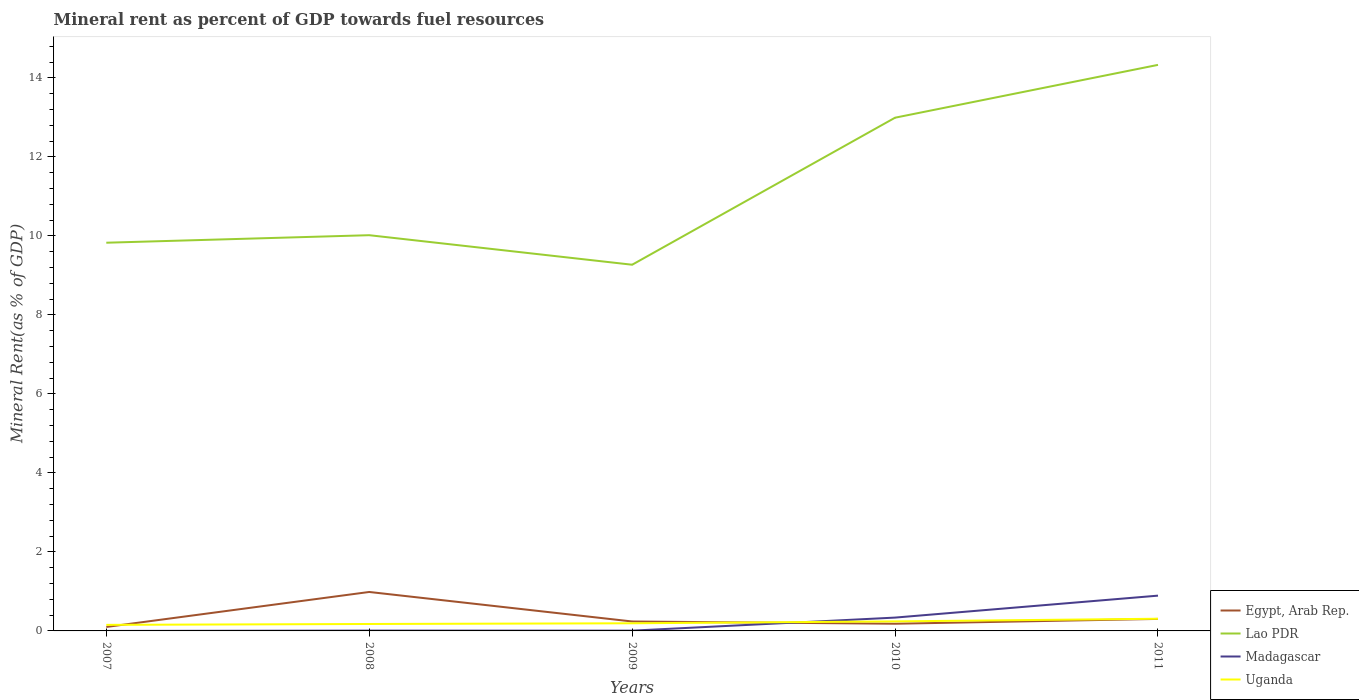Across all years, what is the maximum mineral rent in Lao PDR?
Keep it short and to the point. 9.27. In which year was the mineral rent in Madagascar maximum?
Provide a short and direct response. 2007. What is the total mineral rent in Egypt, Arab Rep. in the graph?
Provide a short and direct response. 0.68. What is the difference between the highest and the second highest mineral rent in Egypt, Arab Rep.?
Provide a succinct answer. 0.89. What is the difference between the highest and the lowest mineral rent in Madagascar?
Give a very brief answer. 2. Is the mineral rent in Lao PDR strictly greater than the mineral rent in Egypt, Arab Rep. over the years?
Offer a very short reply. No. Are the values on the major ticks of Y-axis written in scientific E-notation?
Provide a succinct answer. No. How are the legend labels stacked?
Your answer should be compact. Vertical. What is the title of the graph?
Offer a very short reply. Mineral rent as percent of GDP towards fuel resources. What is the label or title of the X-axis?
Offer a very short reply. Years. What is the label or title of the Y-axis?
Your answer should be very brief. Mineral Rent(as % of GDP). What is the Mineral Rent(as % of GDP) in Egypt, Arab Rep. in 2007?
Make the answer very short. 0.1. What is the Mineral Rent(as % of GDP) of Lao PDR in 2007?
Ensure brevity in your answer.  9.83. What is the Mineral Rent(as % of GDP) in Madagascar in 2007?
Give a very brief answer. 0. What is the Mineral Rent(as % of GDP) in Uganda in 2007?
Ensure brevity in your answer.  0.15. What is the Mineral Rent(as % of GDP) of Egypt, Arab Rep. in 2008?
Offer a very short reply. 0.99. What is the Mineral Rent(as % of GDP) in Lao PDR in 2008?
Provide a short and direct response. 10.02. What is the Mineral Rent(as % of GDP) in Madagascar in 2008?
Offer a very short reply. 0.01. What is the Mineral Rent(as % of GDP) in Uganda in 2008?
Your response must be concise. 0.18. What is the Mineral Rent(as % of GDP) in Egypt, Arab Rep. in 2009?
Provide a succinct answer. 0.24. What is the Mineral Rent(as % of GDP) in Lao PDR in 2009?
Provide a short and direct response. 9.27. What is the Mineral Rent(as % of GDP) in Madagascar in 2009?
Offer a very short reply. 0.01. What is the Mineral Rent(as % of GDP) of Uganda in 2009?
Keep it short and to the point. 0.19. What is the Mineral Rent(as % of GDP) of Egypt, Arab Rep. in 2010?
Your answer should be compact. 0.18. What is the Mineral Rent(as % of GDP) of Lao PDR in 2010?
Offer a very short reply. 12.99. What is the Mineral Rent(as % of GDP) in Madagascar in 2010?
Your response must be concise. 0.34. What is the Mineral Rent(as % of GDP) of Uganda in 2010?
Your response must be concise. 0.24. What is the Mineral Rent(as % of GDP) of Egypt, Arab Rep. in 2011?
Offer a terse response. 0.3. What is the Mineral Rent(as % of GDP) in Lao PDR in 2011?
Provide a succinct answer. 14.33. What is the Mineral Rent(as % of GDP) of Madagascar in 2011?
Keep it short and to the point. 0.89. What is the Mineral Rent(as % of GDP) of Uganda in 2011?
Offer a very short reply. 0.31. Across all years, what is the maximum Mineral Rent(as % of GDP) in Egypt, Arab Rep.?
Provide a short and direct response. 0.99. Across all years, what is the maximum Mineral Rent(as % of GDP) in Lao PDR?
Ensure brevity in your answer.  14.33. Across all years, what is the maximum Mineral Rent(as % of GDP) in Madagascar?
Offer a terse response. 0.89. Across all years, what is the maximum Mineral Rent(as % of GDP) in Uganda?
Provide a succinct answer. 0.31. Across all years, what is the minimum Mineral Rent(as % of GDP) of Egypt, Arab Rep.?
Offer a terse response. 0.1. Across all years, what is the minimum Mineral Rent(as % of GDP) in Lao PDR?
Your answer should be compact. 9.27. Across all years, what is the minimum Mineral Rent(as % of GDP) in Madagascar?
Your response must be concise. 0. Across all years, what is the minimum Mineral Rent(as % of GDP) of Uganda?
Offer a terse response. 0.15. What is the total Mineral Rent(as % of GDP) of Egypt, Arab Rep. in the graph?
Provide a short and direct response. 1.81. What is the total Mineral Rent(as % of GDP) of Lao PDR in the graph?
Offer a very short reply. 56.43. What is the total Mineral Rent(as % of GDP) in Madagascar in the graph?
Ensure brevity in your answer.  1.25. What is the total Mineral Rent(as % of GDP) in Uganda in the graph?
Offer a very short reply. 1.07. What is the difference between the Mineral Rent(as % of GDP) of Egypt, Arab Rep. in 2007 and that in 2008?
Offer a terse response. -0.89. What is the difference between the Mineral Rent(as % of GDP) of Lao PDR in 2007 and that in 2008?
Your answer should be very brief. -0.19. What is the difference between the Mineral Rent(as % of GDP) in Madagascar in 2007 and that in 2008?
Your answer should be compact. -0.01. What is the difference between the Mineral Rent(as % of GDP) of Uganda in 2007 and that in 2008?
Your response must be concise. -0.02. What is the difference between the Mineral Rent(as % of GDP) in Egypt, Arab Rep. in 2007 and that in 2009?
Offer a very short reply. -0.14. What is the difference between the Mineral Rent(as % of GDP) in Lao PDR in 2007 and that in 2009?
Make the answer very short. 0.56. What is the difference between the Mineral Rent(as % of GDP) of Madagascar in 2007 and that in 2009?
Your response must be concise. -0.01. What is the difference between the Mineral Rent(as % of GDP) of Uganda in 2007 and that in 2009?
Ensure brevity in your answer.  -0.04. What is the difference between the Mineral Rent(as % of GDP) of Egypt, Arab Rep. in 2007 and that in 2010?
Your response must be concise. -0.08. What is the difference between the Mineral Rent(as % of GDP) of Lao PDR in 2007 and that in 2010?
Make the answer very short. -3.16. What is the difference between the Mineral Rent(as % of GDP) in Madagascar in 2007 and that in 2010?
Give a very brief answer. -0.34. What is the difference between the Mineral Rent(as % of GDP) in Uganda in 2007 and that in 2010?
Provide a short and direct response. -0.09. What is the difference between the Mineral Rent(as % of GDP) of Egypt, Arab Rep. in 2007 and that in 2011?
Give a very brief answer. -0.2. What is the difference between the Mineral Rent(as % of GDP) of Lao PDR in 2007 and that in 2011?
Your response must be concise. -4.5. What is the difference between the Mineral Rent(as % of GDP) in Madagascar in 2007 and that in 2011?
Make the answer very short. -0.89. What is the difference between the Mineral Rent(as % of GDP) in Uganda in 2007 and that in 2011?
Provide a short and direct response. -0.16. What is the difference between the Mineral Rent(as % of GDP) of Egypt, Arab Rep. in 2008 and that in 2009?
Your answer should be very brief. 0.75. What is the difference between the Mineral Rent(as % of GDP) of Lao PDR in 2008 and that in 2009?
Your answer should be very brief. 0.75. What is the difference between the Mineral Rent(as % of GDP) of Madagascar in 2008 and that in 2009?
Give a very brief answer. 0. What is the difference between the Mineral Rent(as % of GDP) of Uganda in 2008 and that in 2009?
Make the answer very short. -0.02. What is the difference between the Mineral Rent(as % of GDP) in Egypt, Arab Rep. in 2008 and that in 2010?
Your answer should be compact. 0.8. What is the difference between the Mineral Rent(as % of GDP) of Lao PDR in 2008 and that in 2010?
Give a very brief answer. -2.97. What is the difference between the Mineral Rent(as % of GDP) of Madagascar in 2008 and that in 2010?
Provide a succinct answer. -0.33. What is the difference between the Mineral Rent(as % of GDP) of Uganda in 2008 and that in 2010?
Your answer should be compact. -0.07. What is the difference between the Mineral Rent(as % of GDP) in Egypt, Arab Rep. in 2008 and that in 2011?
Ensure brevity in your answer.  0.68. What is the difference between the Mineral Rent(as % of GDP) of Lao PDR in 2008 and that in 2011?
Your response must be concise. -4.31. What is the difference between the Mineral Rent(as % of GDP) in Madagascar in 2008 and that in 2011?
Offer a terse response. -0.88. What is the difference between the Mineral Rent(as % of GDP) in Uganda in 2008 and that in 2011?
Provide a short and direct response. -0.13. What is the difference between the Mineral Rent(as % of GDP) of Egypt, Arab Rep. in 2009 and that in 2010?
Your response must be concise. 0.06. What is the difference between the Mineral Rent(as % of GDP) in Lao PDR in 2009 and that in 2010?
Keep it short and to the point. -3.72. What is the difference between the Mineral Rent(as % of GDP) in Madagascar in 2009 and that in 2010?
Provide a short and direct response. -0.33. What is the difference between the Mineral Rent(as % of GDP) in Uganda in 2009 and that in 2010?
Your answer should be compact. -0.05. What is the difference between the Mineral Rent(as % of GDP) in Egypt, Arab Rep. in 2009 and that in 2011?
Your response must be concise. -0.06. What is the difference between the Mineral Rent(as % of GDP) in Lao PDR in 2009 and that in 2011?
Offer a very short reply. -5.06. What is the difference between the Mineral Rent(as % of GDP) of Madagascar in 2009 and that in 2011?
Your answer should be compact. -0.89. What is the difference between the Mineral Rent(as % of GDP) in Uganda in 2009 and that in 2011?
Offer a very short reply. -0.12. What is the difference between the Mineral Rent(as % of GDP) of Egypt, Arab Rep. in 2010 and that in 2011?
Your answer should be compact. -0.12. What is the difference between the Mineral Rent(as % of GDP) in Lao PDR in 2010 and that in 2011?
Provide a short and direct response. -1.34. What is the difference between the Mineral Rent(as % of GDP) in Madagascar in 2010 and that in 2011?
Provide a short and direct response. -0.56. What is the difference between the Mineral Rent(as % of GDP) of Uganda in 2010 and that in 2011?
Give a very brief answer. -0.07. What is the difference between the Mineral Rent(as % of GDP) in Egypt, Arab Rep. in 2007 and the Mineral Rent(as % of GDP) in Lao PDR in 2008?
Provide a short and direct response. -9.92. What is the difference between the Mineral Rent(as % of GDP) of Egypt, Arab Rep. in 2007 and the Mineral Rent(as % of GDP) of Madagascar in 2008?
Your answer should be compact. 0.09. What is the difference between the Mineral Rent(as % of GDP) in Egypt, Arab Rep. in 2007 and the Mineral Rent(as % of GDP) in Uganda in 2008?
Offer a terse response. -0.08. What is the difference between the Mineral Rent(as % of GDP) in Lao PDR in 2007 and the Mineral Rent(as % of GDP) in Madagascar in 2008?
Ensure brevity in your answer.  9.82. What is the difference between the Mineral Rent(as % of GDP) of Lao PDR in 2007 and the Mineral Rent(as % of GDP) of Uganda in 2008?
Provide a succinct answer. 9.65. What is the difference between the Mineral Rent(as % of GDP) of Madagascar in 2007 and the Mineral Rent(as % of GDP) of Uganda in 2008?
Your answer should be compact. -0.18. What is the difference between the Mineral Rent(as % of GDP) of Egypt, Arab Rep. in 2007 and the Mineral Rent(as % of GDP) of Lao PDR in 2009?
Keep it short and to the point. -9.17. What is the difference between the Mineral Rent(as % of GDP) of Egypt, Arab Rep. in 2007 and the Mineral Rent(as % of GDP) of Madagascar in 2009?
Provide a succinct answer. 0.09. What is the difference between the Mineral Rent(as % of GDP) in Egypt, Arab Rep. in 2007 and the Mineral Rent(as % of GDP) in Uganda in 2009?
Your answer should be very brief. -0.09. What is the difference between the Mineral Rent(as % of GDP) of Lao PDR in 2007 and the Mineral Rent(as % of GDP) of Madagascar in 2009?
Give a very brief answer. 9.82. What is the difference between the Mineral Rent(as % of GDP) of Lao PDR in 2007 and the Mineral Rent(as % of GDP) of Uganda in 2009?
Provide a short and direct response. 9.63. What is the difference between the Mineral Rent(as % of GDP) of Madagascar in 2007 and the Mineral Rent(as % of GDP) of Uganda in 2009?
Offer a very short reply. -0.19. What is the difference between the Mineral Rent(as % of GDP) of Egypt, Arab Rep. in 2007 and the Mineral Rent(as % of GDP) of Lao PDR in 2010?
Offer a terse response. -12.89. What is the difference between the Mineral Rent(as % of GDP) of Egypt, Arab Rep. in 2007 and the Mineral Rent(as % of GDP) of Madagascar in 2010?
Offer a terse response. -0.24. What is the difference between the Mineral Rent(as % of GDP) in Egypt, Arab Rep. in 2007 and the Mineral Rent(as % of GDP) in Uganda in 2010?
Ensure brevity in your answer.  -0.14. What is the difference between the Mineral Rent(as % of GDP) of Lao PDR in 2007 and the Mineral Rent(as % of GDP) of Madagascar in 2010?
Keep it short and to the point. 9.49. What is the difference between the Mineral Rent(as % of GDP) of Lao PDR in 2007 and the Mineral Rent(as % of GDP) of Uganda in 2010?
Offer a very short reply. 9.58. What is the difference between the Mineral Rent(as % of GDP) of Madagascar in 2007 and the Mineral Rent(as % of GDP) of Uganda in 2010?
Your answer should be very brief. -0.24. What is the difference between the Mineral Rent(as % of GDP) of Egypt, Arab Rep. in 2007 and the Mineral Rent(as % of GDP) of Lao PDR in 2011?
Make the answer very short. -14.23. What is the difference between the Mineral Rent(as % of GDP) of Egypt, Arab Rep. in 2007 and the Mineral Rent(as % of GDP) of Madagascar in 2011?
Offer a terse response. -0.79. What is the difference between the Mineral Rent(as % of GDP) in Egypt, Arab Rep. in 2007 and the Mineral Rent(as % of GDP) in Uganda in 2011?
Provide a succinct answer. -0.21. What is the difference between the Mineral Rent(as % of GDP) in Lao PDR in 2007 and the Mineral Rent(as % of GDP) in Madagascar in 2011?
Your answer should be very brief. 8.93. What is the difference between the Mineral Rent(as % of GDP) of Lao PDR in 2007 and the Mineral Rent(as % of GDP) of Uganda in 2011?
Offer a very short reply. 9.52. What is the difference between the Mineral Rent(as % of GDP) of Madagascar in 2007 and the Mineral Rent(as % of GDP) of Uganda in 2011?
Ensure brevity in your answer.  -0.31. What is the difference between the Mineral Rent(as % of GDP) in Egypt, Arab Rep. in 2008 and the Mineral Rent(as % of GDP) in Lao PDR in 2009?
Keep it short and to the point. -8.28. What is the difference between the Mineral Rent(as % of GDP) of Egypt, Arab Rep. in 2008 and the Mineral Rent(as % of GDP) of Madagascar in 2009?
Your response must be concise. 0.98. What is the difference between the Mineral Rent(as % of GDP) in Egypt, Arab Rep. in 2008 and the Mineral Rent(as % of GDP) in Uganda in 2009?
Your answer should be very brief. 0.79. What is the difference between the Mineral Rent(as % of GDP) in Lao PDR in 2008 and the Mineral Rent(as % of GDP) in Madagascar in 2009?
Your response must be concise. 10.01. What is the difference between the Mineral Rent(as % of GDP) in Lao PDR in 2008 and the Mineral Rent(as % of GDP) in Uganda in 2009?
Give a very brief answer. 9.82. What is the difference between the Mineral Rent(as % of GDP) in Madagascar in 2008 and the Mineral Rent(as % of GDP) in Uganda in 2009?
Offer a terse response. -0.19. What is the difference between the Mineral Rent(as % of GDP) in Egypt, Arab Rep. in 2008 and the Mineral Rent(as % of GDP) in Lao PDR in 2010?
Make the answer very short. -12. What is the difference between the Mineral Rent(as % of GDP) of Egypt, Arab Rep. in 2008 and the Mineral Rent(as % of GDP) of Madagascar in 2010?
Your answer should be very brief. 0.65. What is the difference between the Mineral Rent(as % of GDP) of Egypt, Arab Rep. in 2008 and the Mineral Rent(as % of GDP) of Uganda in 2010?
Your response must be concise. 0.74. What is the difference between the Mineral Rent(as % of GDP) of Lao PDR in 2008 and the Mineral Rent(as % of GDP) of Madagascar in 2010?
Your answer should be compact. 9.68. What is the difference between the Mineral Rent(as % of GDP) in Lao PDR in 2008 and the Mineral Rent(as % of GDP) in Uganda in 2010?
Keep it short and to the point. 9.78. What is the difference between the Mineral Rent(as % of GDP) in Madagascar in 2008 and the Mineral Rent(as % of GDP) in Uganda in 2010?
Your answer should be compact. -0.23. What is the difference between the Mineral Rent(as % of GDP) of Egypt, Arab Rep. in 2008 and the Mineral Rent(as % of GDP) of Lao PDR in 2011?
Make the answer very short. -13.34. What is the difference between the Mineral Rent(as % of GDP) of Egypt, Arab Rep. in 2008 and the Mineral Rent(as % of GDP) of Madagascar in 2011?
Offer a very short reply. 0.09. What is the difference between the Mineral Rent(as % of GDP) in Egypt, Arab Rep. in 2008 and the Mineral Rent(as % of GDP) in Uganda in 2011?
Ensure brevity in your answer.  0.68. What is the difference between the Mineral Rent(as % of GDP) in Lao PDR in 2008 and the Mineral Rent(as % of GDP) in Madagascar in 2011?
Your answer should be very brief. 9.12. What is the difference between the Mineral Rent(as % of GDP) in Lao PDR in 2008 and the Mineral Rent(as % of GDP) in Uganda in 2011?
Ensure brevity in your answer.  9.71. What is the difference between the Mineral Rent(as % of GDP) in Madagascar in 2008 and the Mineral Rent(as % of GDP) in Uganda in 2011?
Provide a succinct answer. -0.3. What is the difference between the Mineral Rent(as % of GDP) in Egypt, Arab Rep. in 2009 and the Mineral Rent(as % of GDP) in Lao PDR in 2010?
Your answer should be compact. -12.75. What is the difference between the Mineral Rent(as % of GDP) of Egypt, Arab Rep. in 2009 and the Mineral Rent(as % of GDP) of Madagascar in 2010?
Give a very brief answer. -0.1. What is the difference between the Mineral Rent(as % of GDP) of Egypt, Arab Rep. in 2009 and the Mineral Rent(as % of GDP) of Uganda in 2010?
Keep it short and to the point. -0. What is the difference between the Mineral Rent(as % of GDP) of Lao PDR in 2009 and the Mineral Rent(as % of GDP) of Madagascar in 2010?
Your answer should be compact. 8.93. What is the difference between the Mineral Rent(as % of GDP) in Lao PDR in 2009 and the Mineral Rent(as % of GDP) in Uganda in 2010?
Your answer should be compact. 9.03. What is the difference between the Mineral Rent(as % of GDP) in Madagascar in 2009 and the Mineral Rent(as % of GDP) in Uganda in 2010?
Ensure brevity in your answer.  -0.23. What is the difference between the Mineral Rent(as % of GDP) of Egypt, Arab Rep. in 2009 and the Mineral Rent(as % of GDP) of Lao PDR in 2011?
Make the answer very short. -14.09. What is the difference between the Mineral Rent(as % of GDP) of Egypt, Arab Rep. in 2009 and the Mineral Rent(as % of GDP) of Madagascar in 2011?
Offer a very short reply. -0.65. What is the difference between the Mineral Rent(as % of GDP) of Egypt, Arab Rep. in 2009 and the Mineral Rent(as % of GDP) of Uganda in 2011?
Provide a short and direct response. -0.07. What is the difference between the Mineral Rent(as % of GDP) in Lao PDR in 2009 and the Mineral Rent(as % of GDP) in Madagascar in 2011?
Offer a terse response. 8.38. What is the difference between the Mineral Rent(as % of GDP) of Lao PDR in 2009 and the Mineral Rent(as % of GDP) of Uganda in 2011?
Give a very brief answer. 8.96. What is the difference between the Mineral Rent(as % of GDP) in Madagascar in 2009 and the Mineral Rent(as % of GDP) in Uganda in 2011?
Your answer should be compact. -0.3. What is the difference between the Mineral Rent(as % of GDP) of Egypt, Arab Rep. in 2010 and the Mineral Rent(as % of GDP) of Lao PDR in 2011?
Make the answer very short. -14.15. What is the difference between the Mineral Rent(as % of GDP) in Egypt, Arab Rep. in 2010 and the Mineral Rent(as % of GDP) in Madagascar in 2011?
Provide a succinct answer. -0.71. What is the difference between the Mineral Rent(as % of GDP) of Egypt, Arab Rep. in 2010 and the Mineral Rent(as % of GDP) of Uganda in 2011?
Provide a short and direct response. -0.13. What is the difference between the Mineral Rent(as % of GDP) in Lao PDR in 2010 and the Mineral Rent(as % of GDP) in Madagascar in 2011?
Provide a succinct answer. 12.1. What is the difference between the Mineral Rent(as % of GDP) of Lao PDR in 2010 and the Mineral Rent(as % of GDP) of Uganda in 2011?
Your answer should be compact. 12.68. What is the difference between the Mineral Rent(as % of GDP) of Madagascar in 2010 and the Mineral Rent(as % of GDP) of Uganda in 2011?
Your answer should be compact. 0.03. What is the average Mineral Rent(as % of GDP) of Egypt, Arab Rep. per year?
Your answer should be very brief. 0.36. What is the average Mineral Rent(as % of GDP) in Lao PDR per year?
Your answer should be very brief. 11.29. What is the average Mineral Rent(as % of GDP) of Madagascar per year?
Your answer should be very brief. 0.25. What is the average Mineral Rent(as % of GDP) of Uganda per year?
Give a very brief answer. 0.21. In the year 2007, what is the difference between the Mineral Rent(as % of GDP) in Egypt, Arab Rep. and Mineral Rent(as % of GDP) in Lao PDR?
Your response must be concise. -9.73. In the year 2007, what is the difference between the Mineral Rent(as % of GDP) of Egypt, Arab Rep. and Mineral Rent(as % of GDP) of Madagascar?
Your answer should be compact. 0.1. In the year 2007, what is the difference between the Mineral Rent(as % of GDP) of Egypt, Arab Rep. and Mineral Rent(as % of GDP) of Uganda?
Your answer should be very brief. -0.05. In the year 2007, what is the difference between the Mineral Rent(as % of GDP) of Lao PDR and Mineral Rent(as % of GDP) of Madagascar?
Your response must be concise. 9.83. In the year 2007, what is the difference between the Mineral Rent(as % of GDP) in Lao PDR and Mineral Rent(as % of GDP) in Uganda?
Offer a terse response. 9.67. In the year 2007, what is the difference between the Mineral Rent(as % of GDP) of Madagascar and Mineral Rent(as % of GDP) of Uganda?
Offer a very short reply. -0.15. In the year 2008, what is the difference between the Mineral Rent(as % of GDP) of Egypt, Arab Rep. and Mineral Rent(as % of GDP) of Lao PDR?
Offer a terse response. -9.03. In the year 2008, what is the difference between the Mineral Rent(as % of GDP) of Egypt, Arab Rep. and Mineral Rent(as % of GDP) of Madagascar?
Keep it short and to the point. 0.98. In the year 2008, what is the difference between the Mineral Rent(as % of GDP) in Egypt, Arab Rep. and Mineral Rent(as % of GDP) in Uganda?
Provide a short and direct response. 0.81. In the year 2008, what is the difference between the Mineral Rent(as % of GDP) of Lao PDR and Mineral Rent(as % of GDP) of Madagascar?
Provide a succinct answer. 10.01. In the year 2008, what is the difference between the Mineral Rent(as % of GDP) of Lao PDR and Mineral Rent(as % of GDP) of Uganda?
Make the answer very short. 9.84. In the year 2008, what is the difference between the Mineral Rent(as % of GDP) of Madagascar and Mineral Rent(as % of GDP) of Uganda?
Ensure brevity in your answer.  -0.17. In the year 2009, what is the difference between the Mineral Rent(as % of GDP) of Egypt, Arab Rep. and Mineral Rent(as % of GDP) of Lao PDR?
Provide a short and direct response. -9.03. In the year 2009, what is the difference between the Mineral Rent(as % of GDP) of Egypt, Arab Rep. and Mineral Rent(as % of GDP) of Madagascar?
Your response must be concise. 0.23. In the year 2009, what is the difference between the Mineral Rent(as % of GDP) of Egypt, Arab Rep. and Mineral Rent(as % of GDP) of Uganda?
Your answer should be very brief. 0.05. In the year 2009, what is the difference between the Mineral Rent(as % of GDP) in Lao PDR and Mineral Rent(as % of GDP) in Madagascar?
Your response must be concise. 9.26. In the year 2009, what is the difference between the Mineral Rent(as % of GDP) in Lao PDR and Mineral Rent(as % of GDP) in Uganda?
Offer a very short reply. 9.08. In the year 2009, what is the difference between the Mineral Rent(as % of GDP) in Madagascar and Mineral Rent(as % of GDP) in Uganda?
Your answer should be compact. -0.19. In the year 2010, what is the difference between the Mineral Rent(as % of GDP) of Egypt, Arab Rep. and Mineral Rent(as % of GDP) of Lao PDR?
Ensure brevity in your answer.  -12.81. In the year 2010, what is the difference between the Mineral Rent(as % of GDP) of Egypt, Arab Rep. and Mineral Rent(as % of GDP) of Madagascar?
Provide a succinct answer. -0.16. In the year 2010, what is the difference between the Mineral Rent(as % of GDP) of Egypt, Arab Rep. and Mineral Rent(as % of GDP) of Uganda?
Offer a very short reply. -0.06. In the year 2010, what is the difference between the Mineral Rent(as % of GDP) of Lao PDR and Mineral Rent(as % of GDP) of Madagascar?
Provide a succinct answer. 12.65. In the year 2010, what is the difference between the Mineral Rent(as % of GDP) of Lao PDR and Mineral Rent(as % of GDP) of Uganda?
Provide a short and direct response. 12.75. In the year 2010, what is the difference between the Mineral Rent(as % of GDP) in Madagascar and Mineral Rent(as % of GDP) in Uganda?
Offer a terse response. 0.1. In the year 2011, what is the difference between the Mineral Rent(as % of GDP) in Egypt, Arab Rep. and Mineral Rent(as % of GDP) in Lao PDR?
Give a very brief answer. -14.02. In the year 2011, what is the difference between the Mineral Rent(as % of GDP) in Egypt, Arab Rep. and Mineral Rent(as % of GDP) in Madagascar?
Offer a very short reply. -0.59. In the year 2011, what is the difference between the Mineral Rent(as % of GDP) in Egypt, Arab Rep. and Mineral Rent(as % of GDP) in Uganda?
Offer a very short reply. -0. In the year 2011, what is the difference between the Mineral Rent(as % of GDP) in Lao PDR and Mineral Rent(as % of GDP) in Madagascar?
Your response must be concise. 13.43. In the year 2011, what is the difference between the Mineral Rent(as % of GDP) of Lao PDR and Mineral Rent(as % of GDP) of Uganda?
Provide a short and direct response. 14.02. In the year 2011, what is the difference between the Mineral Rent(as % of GDP) in Madagascar and Mineral Rent(as % of GDP) in Uganda?
Make the answer very short. 0.58. What is the ratio of the Mineral Rent(as % of GDP) in Egypt, Arab Rep. in 2007 to that in 2008?
Your response must be concise. 0.1. What is the ratio of the Mineral Rent(as % of GDP) of Madagascar in 2007 to that in 2008?
Ensure brevity in your answer.  0.02. What is the ratio of the Mineral Rent(as % of GDP) of Uganda in 2007 to that in 2008?
Provide a succinct answer. 0.87. What is the ratio of the Mineral Rent(as % of GDP) in Egypt, Arab Rep. in 2007 to that in 2009?
Make the answer very short. 0.42. What is the ratio of the Mineral Rent(as % of GDP) in Lao PDR in 2007 to that in 2009?
Give a very brief answer. 1.06. What is the ratio of the Mineral Rent(as % of GDP) of Madagascar in 2007 to that in 2009?
Offer a terse response. 0.02. What is the ratio of the Mineral Rent(as % of GDP) in Uganda in 2007 to that in 2009?
Offer a very short reply. 0.79. What is the ratio of the Mineral Rent(as % of GDP) of Egypt, Arab Rep. in 2007 to that in 2010?
Keep it short and to the point. 0.55. What is the ratio of the Mineral Rent(as % of GDP) of Lao PDR in 2007 to that in 2010?
Provide a short and direct response. 0.76. What is the ratio of the Mineral Rent(as % of GDP) of Madagascar in 2007 to that in 2010?
Ensure brevity in your answer.  0. What is the ratio of the Mineral Rent(as % of GDP) in Uganda in 2007 to that in 2010?
Ensure brevity in your answer.  0.64. What is the ratio of the Mineral Rent(as % of GDP) in Egypt, Arab Rep. in 2007 to that in 2011?
Your response must be concise. 0.33. What is the ratio of the Mineral Rent(as % of GDP) in Lao PDR in 2007 to that in 2011?
Keep it short and to the point. 0.69. What is the ratio of the Mineral Rent(as % of GDP) of Madagascar in 2007 to that in 2011?
Your answer should be compact. 0. What is the ratio of the Mineral Rent(as % of GDP) of Uganda in 2007 to that in 2011?
Your answer should be compact. 0.5. What is the ratio of the Mineral Rent(as % of GDP) in Egypt, Arab Rep. in 2008 to that in 2009?
Provide a succinct answer. 4.13. What is the ratio of the Mineral Rent(as % of GDP) in Lao PDR in 2008 to that in 2009?
Your answer should be compact. 1.08. What is the ratio of the Mineral Rent(as % of GDP) of Madagascar in 2008 to that in 2009?
Offer a very short reply. 1.16. What is the ratio of the Mineral Rent(as % of GDP) in Uganda in 2008 to that in 2009?
Provide a short and direct response. 0.91. What is the ratio of the Mineral Rent(as % of GDP) of Egypt, Arab Rep. in 2008 to that in 2010?
Your answer should be compact. 5.42. What is the ratio of the Mineral Rent(as % of GDP) of Lao PDR in 2008 to that in 2010?
Make the answer very short. 0.77. What is the ratio of the Mineral Rent(as % of GDP) of Madagascar in 2008 to that in 2010?
Ensure brevity in your answer.  0.02. What is the ratio of the Mineral Rent(as % of GDP) in Uganda in 2008 to that in 2010?
Make the answer very short. 0.73. What is the ratio of the Mineral Rent(as % of GDP) of Egypt, Arab Rep. in 2008 to that in 2011?
Your answer should be compact. 3.25. What is the ratio of the Mineral Rent(as % of GDP) in Lao PDR in 2008 to that in 2011?
Keep it short and to the point. 0.7. What is the ratio of the Mineral Rent(as % of GDP) in Madagascar in 2008 to that in 2011?
Offer a terse response. 0.01. What is the ratio of the Mineral Rent(as % of GDP) in Uganda in 2008 to that in 2011?
Ensure brevity in your answer.  0.57. What is the ratio of the Mineral Rent(as % of GDP) of Egypt, Arab Rep. in 2009 to that in 2010?
Give a very brief answer. 1.31. What is the ratio of the Mineral Rent(as % of GDP) of Lao PDR in 2009 to that in 2010?
Your answer should be compact. 0.71. What is the ratio of the Mineral Rent(as % of GDP) of Madagascar in 2009 to that in 2010?
Offer a terse response. 0.02. What is the ratio of the Mineral Rent(as % of GDP) of Uganda in 2009 to that in 2010?
Offer a very short reply. 0.8. What is the ratio of the Mineral Rent(as % of GDP) of Egypt, Arab Rep. in 2009 to that in 2011?
Give a very brief answer. 0.79. What is the ratio of the Mineral Rent(as % of GDP) of Lao PDR in 2009 to that in 2011?
Provide a succinct answer. 0.65. What is the ratio of the Mineral Rent(as % of GDP) of Madagascar in 2009 to that in 2011?
Make the answer very short. 0.01. What is the ratio of the Mineral Rent(as % of GDP) in Uganda in 2009 to that in 2011?
Keep it short and to the point. 0.63. What is the ratio of the Mineral Rent(as % of GDP) of Egypt, Arab Rep. in 2010 to that in 2011?
Provide a short and direct response. 0.6. What is the ratio of the Mineral Rent(as % of GDP) of Lao PDR in 2010 to that in 2011?
Make the answer very short. 0.91. What is the ratio of the Mineral Rent(as % of GDP) of Madagascar in 2010 to that in 2011?
Your answer should be very brief. 0.38. What is the ratio of the Mineral Rent(as % of GDP) of Uganda in 2010 to that in 2011?
Keep it short and to the point. 0.78. What is the difference between the highest and the second highest Mineral Rent(as % of GDP) in Egypt, Arab Rep.?
Your response must be concise. 0.68. What is the difference between the highest and the second highest Mineral Rent(as % of GDP) of Lao PDR?
Your answer should be compact. 1.34. What is the difference between the highest and the second highest Mineral Rent(as % of GDP) in Madagascar?
Make the answer very short. 0.56. What is the difference between the highest and the second highest Mineral Rent(as % of GDP) in Uganda?
Offer a very short reply. 0.07. What is the difference between the highest and the lowest Mineral Rent(as % of GDP) in Egypt, Arab Rep.?
Offer a very short reply. 0.89. What is the difference between the highest and the lowest Mineral Rent(as % of GDP) in Lao PDR?
Your response must be concise. 5.06. What is the difference between the highest and the lowest Mineral Rent(as % of GDP) in Madagascar?
Your answer should be very brief. 0.89. What is the difference between the highest and the lowest Mineral Rent(as % of GDP) of Uganda?
Keep it short and to the point. 0.16. 